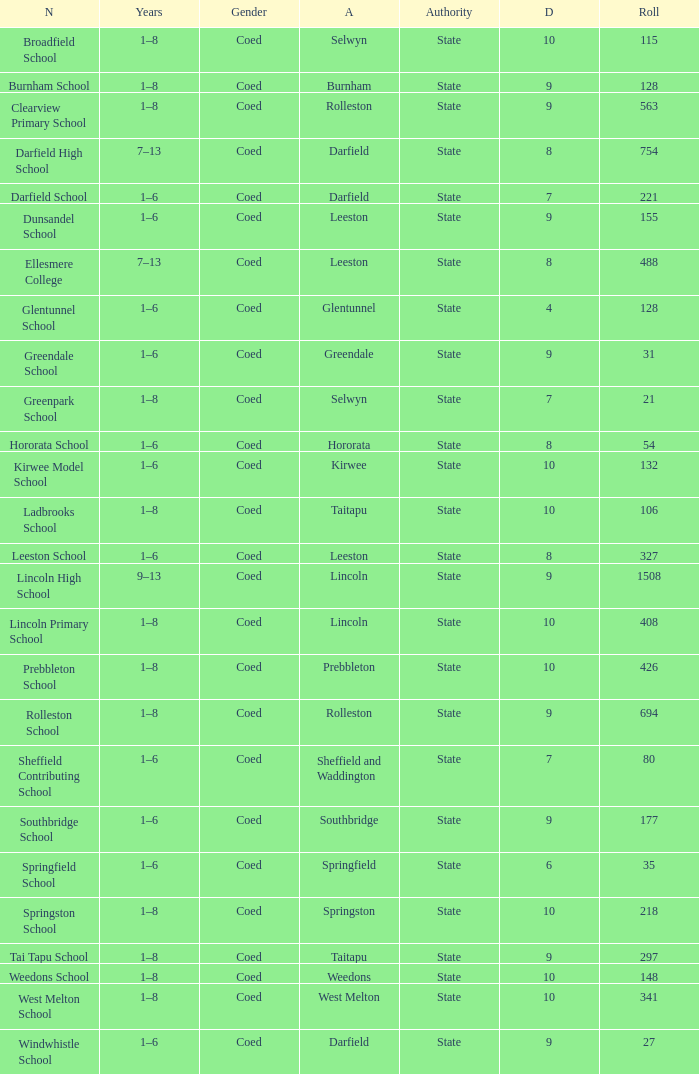What is the total of the roll with a Decile of 8, and an Area of hororata? 54.0. 